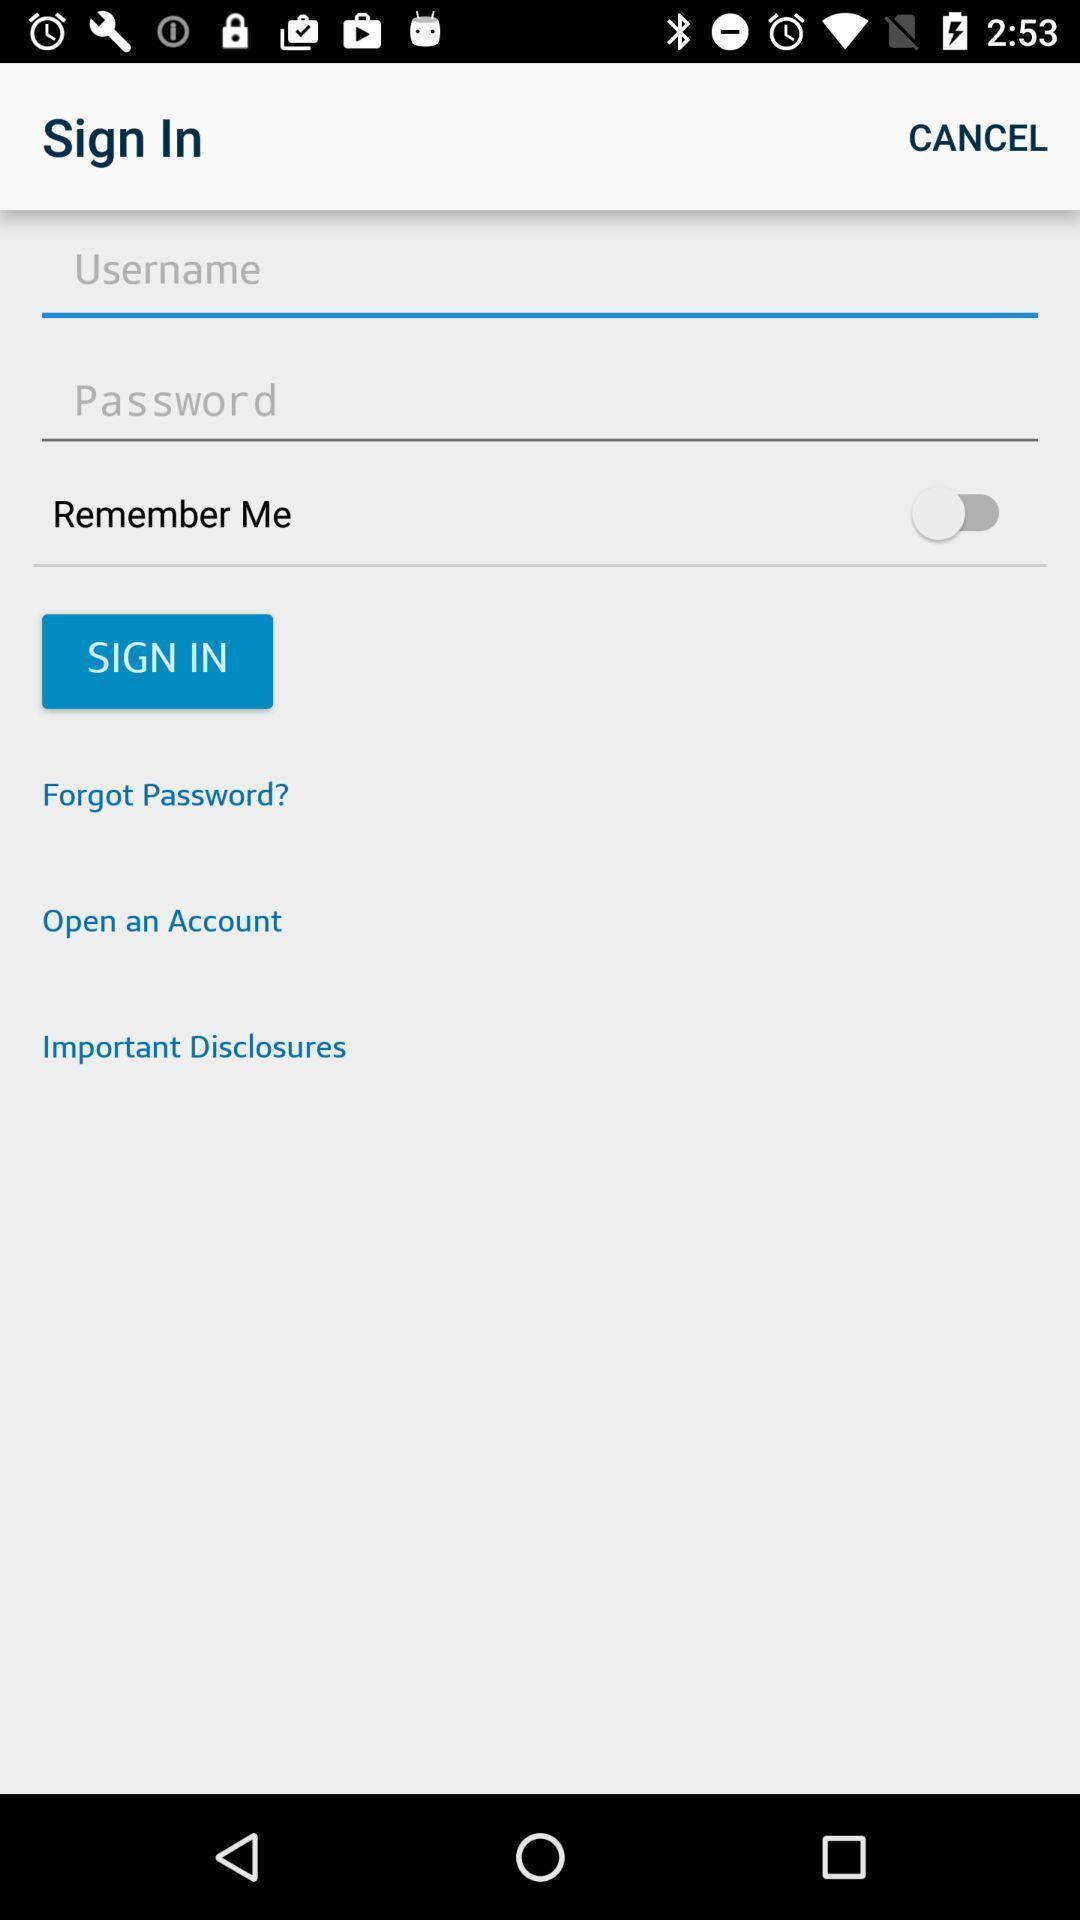Provide a textual representation of this image. Welcome and log-in page for an application. 